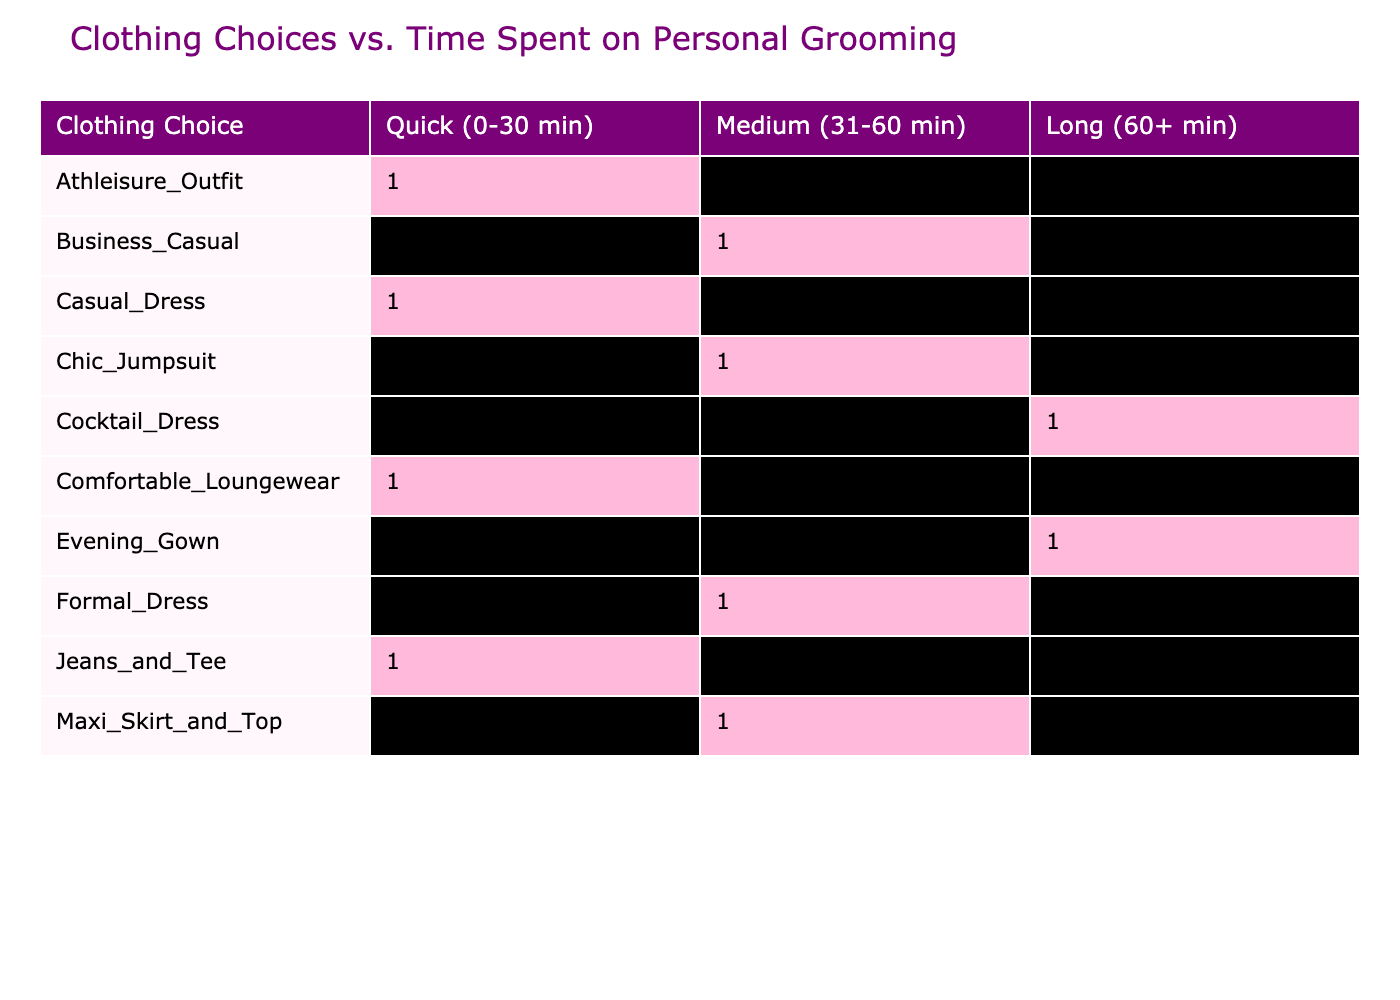What clothing choice has the longest grooming time? The grooming times are listed for each clothing choice, and the 'Evening Gown' has the highest grooming time at 90 minutes.
Answer: Evening Gown How many clothing choices fall into the 'Quick (0-30 min)' category? From the table, we see 'Casual Dress', 'Jeans and Tee', and 'Comfortable Loungewear' listed under the 'Quick' category, which makes a total of 3.
Answer: 3 What is the average time spent on personal grooming for medium category choices? The medium category choices are 'Formal Dress', 'Maxi Skirt and Top', and 'Business Casual' with grooming times of 60, 45, and 40 respectively. Adding these gives 145 minutes. Dividing by 3 (the number of choices) results in an average of 48.33 minutes.
Answer: 48.33 Is there any clothing choice that requires more than 60 minutes of grooming time? The 'Cocktail Dress' and 'Evening Gown' both require more than 60 minutes for grooming since they have grooming times of 75 and 90 minutes respectively.
Answer: Yes Which clothing category has the least time spent on personal grooming? From the table, 'Comfortable Loungewear' has the lowest grooming time listed at only 10 minutes.
Answer: Comfortable Loungewear What is the total grooming time for clothing choices that require a medium amount of grooming? The clothing choices that require medium grooming are 'Formal Dress', 'Maxi Skirt and Top', and 'Business Casual', with times of 60, 45, and 40 minutes respectively. Adding these up gives 145 minutes total.
Answer: 145 minutes How many clothing choices take longer than 40 minutes for grooming? The clothing choices that take longer than 40 minutes are 'Formal Dress', 'Maxi Skirt and Top', 'Cocktail Dress', and 'Evening Gown'. This results in a total of 4 choices.
Answer: 4 What is the difference in grooming time between the 'Evening Gown' and 'Comfortable Loungewear'? The grooming time for 'Evening Gown' is 90 minutes, while for 'Comfortable Loungewear' it is 10 minutes. The difference is calculated as 90 - 10 = 80 minutes.
Answer: 80 minutes 